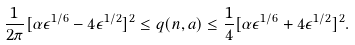Convert formula to latex. <formula><loc_0><loc_0><loc_500><loc_500>\frac { 1 } { 2 \pi } [ \alpha \epsilon ^ { 1 / 6 } - 4 \epsilon ^ { 1 / 2 } ] ^ { 2 } \leq q ( n , a ) \leq \frac { 1 } { 4 } [ \alpha \epsilon ^ { 1 / 6 } + 4 \epsilon ^ { 1 / 2 } ] ^ { 2 } .</formula> 